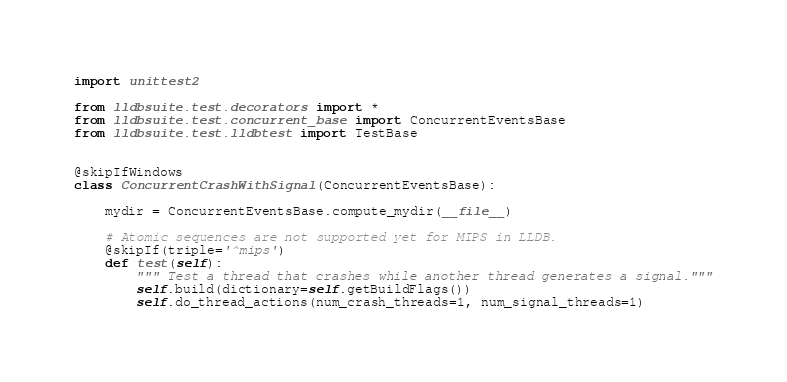<code> <loc_0><loc_0><loc_500><loc_500><_Python_>
import unittest2

from lldbsuite.test.decorators import *
from lldbsuite.test.concurrent_base import ConcurrentEventsBase
from lldbsuite.test.lldbtest import TestBase


@skipIfWindows
class ConcurrentCrashWithSignal(ConcurrentEventsBase):

    mydir = ConcurrentEventsBase.compute_mydir(__file__)

    # Atomic sequences are not supported yet for MIPS in LLDB.
    @skipIf(triple='^mips')
    def test(self):
        """ Test a thread that crashes while another thread generates a signal."""
        self.build(dictionary=self.getBuildFlags())
        self.do_thread_actions(num_crash_threads=1, num_signal_threads=1)
</code> 